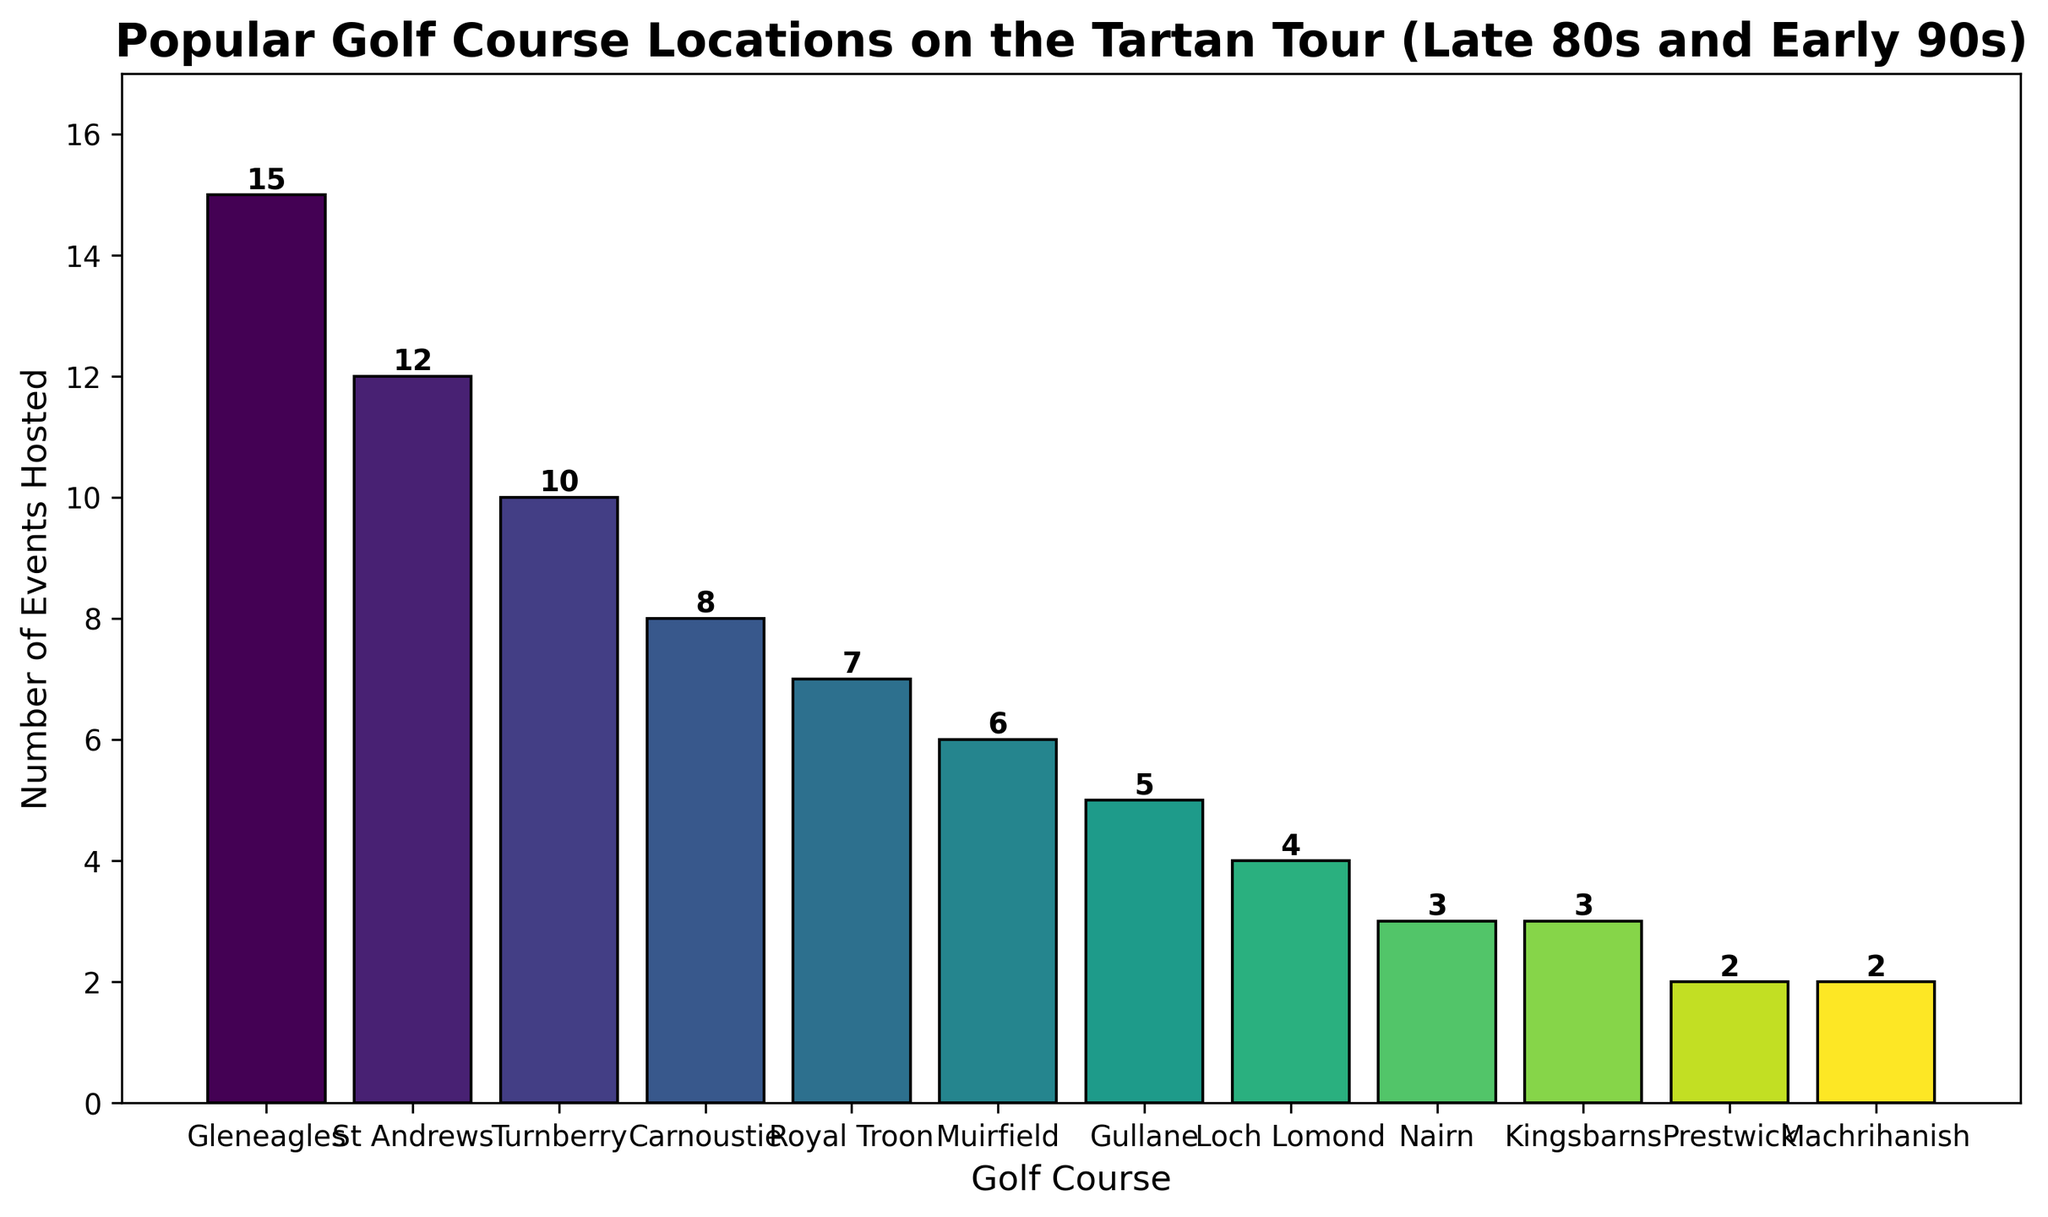What's the total number of events hosted by Gleneagles, St Andrews, and Turnberry? Sum the number of events hosted by Gleneagles (15), St Andrews (12), and Turnberry (10), which is 15 + 12 + 10 = 37
Answer: 37 Which golf course hosted the highest number of events? Identify the bar with the highest value. The highest bar corresponds to Gleneagles with 15 events
Answer: Gleneagles Which golf course hosted fewer events: Muirfield or Gullane? Compare the heights of the bars for Muirfield (6 events) and Gullane (5 events). Muirfield's bar is higher, so Gullane hosted fewer events.
Answer: Gullane How many more events did Carnoustie host compared to Nairn? Find the difference between events hosted by Carnoustie (8) and Nairn (3), which is 8 - 3 = 5
Answer: 5 What is the total number of events hosted by all courses combined? Sum all the events hosted by each course: 15 + 12 + 10 + 8 + 7 + 6 + 5 + 4 + 3 + 3 + 2 + 2 = 77
Answer: 77 What's the median number of events hosted across all courses listed? List the events in ascending order: 2, 2, 3, 3, 4, 5, 6, 7, 8, 10, 12, 15. For 12 values, the median is the average of the 6th and 7th values, which are 5 and 6. So, (5 + 6) / 2 = 5.5
Answer: 5.5 Did Loch Lomond host more events than Kingsbarns? Compare the heights of the bars for Loch Lomond (4 events) and Kingsbarns (3 events). Loch Lomond's bar is higher, so it hosted more events.
Answer: Yes Which two courses hosted the same number of events? Identify bars with the same height. Nairn and Kingsbarns both hosted 3 events, and Prestwick and Machrihanish both hosted 2 events.
Answer: Nairn and Kingsbarns, Prestwick and Machrihanish Is the number of events hosted by Royal Troon more or less than half the number hosted by Gleneagles? Calculate half the number of events hosted by Gleneagles, which is 15 / 2 = 7.5. Compare this to the events hosted by Royal Troon (7). Since 7 is less than 7.5, Royal Troon hosted fewer events.
Answer: Less 